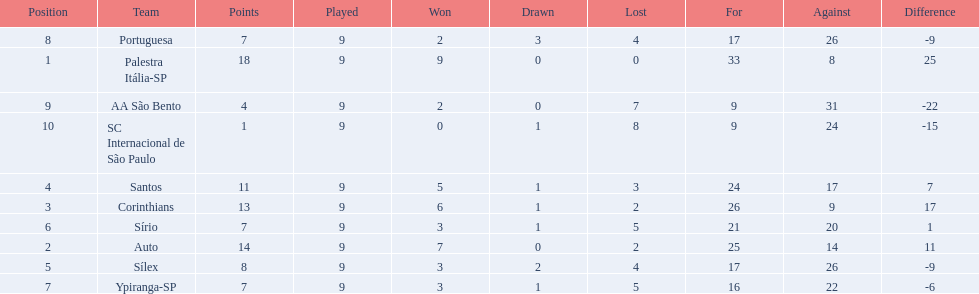How many games did each team play? 9, 9, 9, 9, 9, 9, 9, 9, 9, 9. Did any team score 13 points in the total games they played? 13. What is the name of that team? Corinthians. 